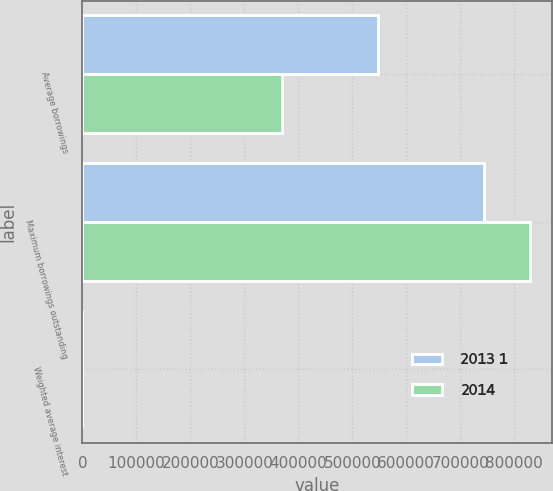Convert chart to OTSL. <chart><loc_0><loc_0><loc_500><loc_500><stacked_bar_chart><ecel><fcel>Average borrowings<fcel>Maximum borrowings outstanding<fcel>Weighted average interest<nl><fcel>2013 1<fcel>548530<fcel>745000<fcel>0.42<nl><fcel>2014<fcel>370420<fcel>829250<fcel>0.36<nl></chart> 